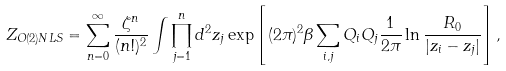<formula> <loc_0><loc_0><loc_500><loc_500>Z _ { O ( 2 ) N L S } = \sum _ { n = 0 } ^ { \infty } { \frac { \zeta ^ { n } } { ( n ! ) ^ { 2 } } } \int \prod _ { j = 1 } ^ { n } d ^ { 2 } z _ { j } \exp \left [ ( 2 \pi ) ^ { 2 } \beta \sum _ { i , j } Q _ { i } Q _ { j } { \frac { 1 } { 2 \pi } } \ln { \frac { R _ { 0 } } { | z _ { i } - z _ { j } | } } \right ] ,</formula> 